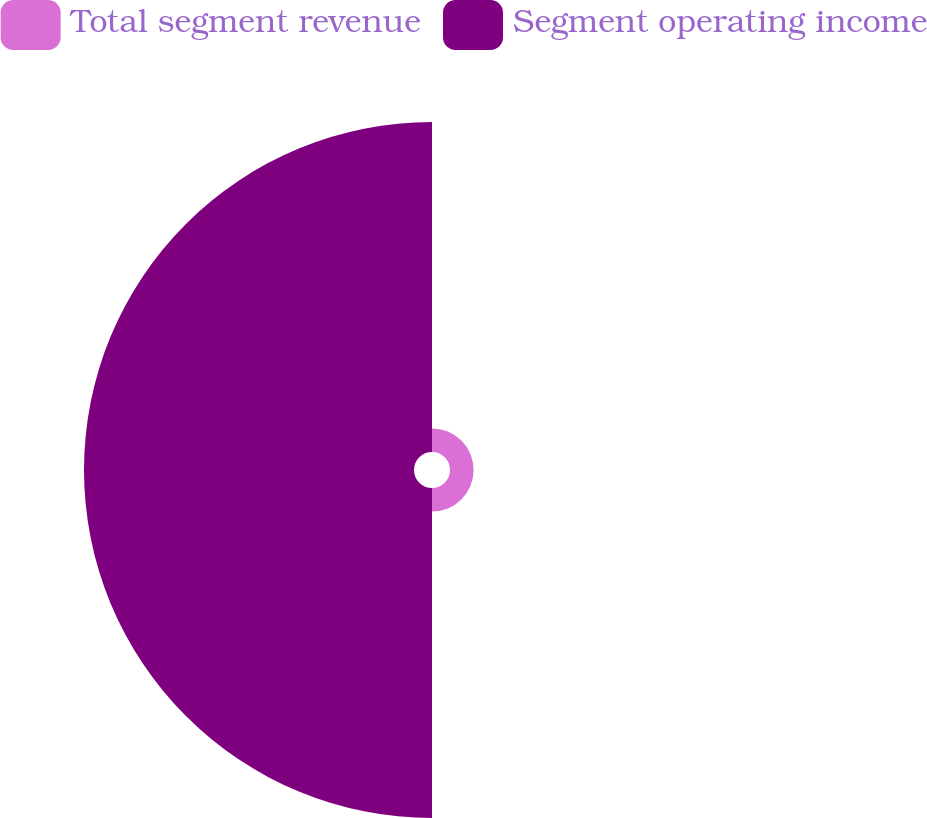<chart> <loc_0><loc_0><loc_500><loc_500><pie_chart><fcel>Total segment revenue<fcel>Segment operating income<nl><fcel>6.67%<fcel>93.33%<nl></chart> 